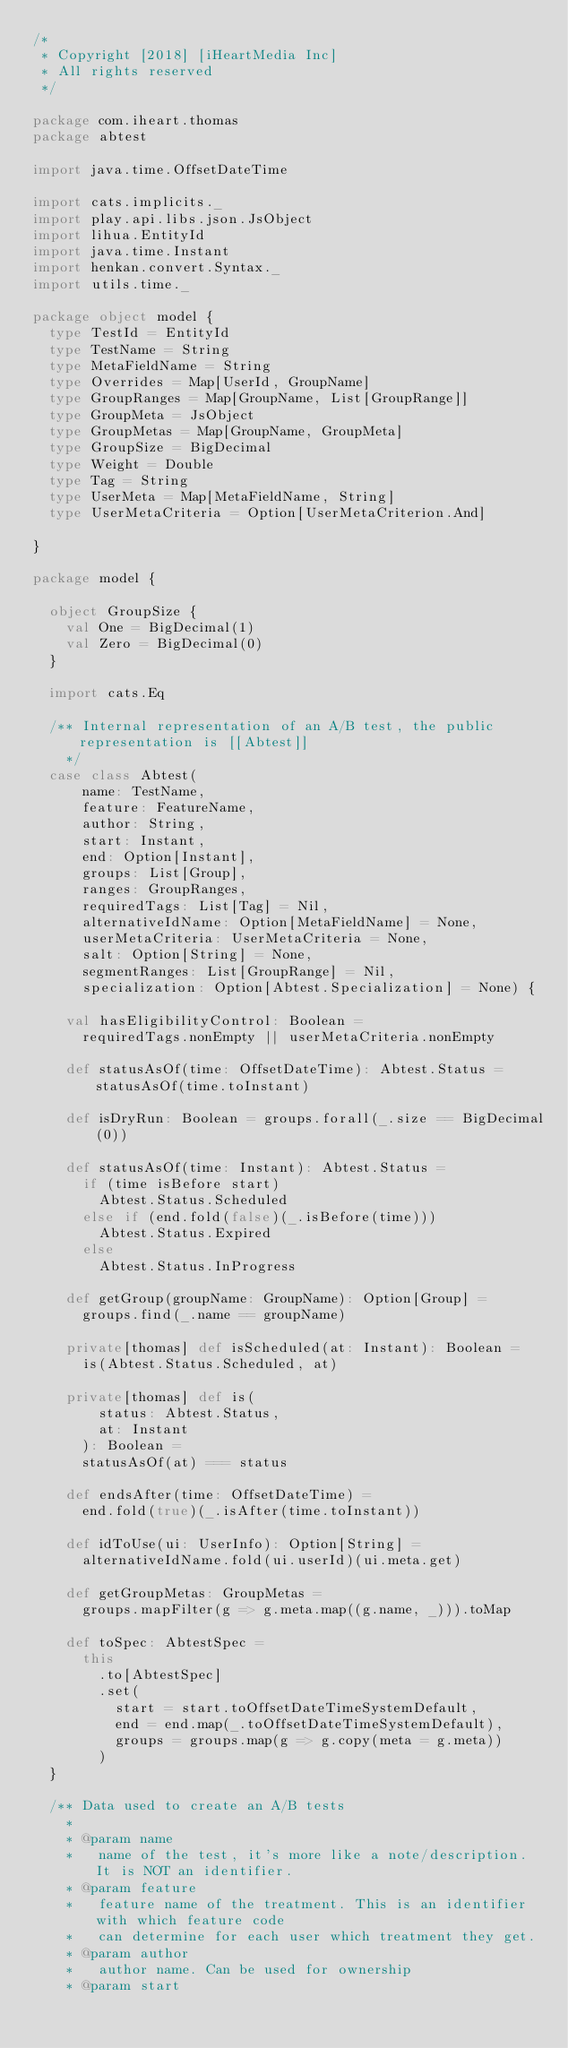Convert code to text. <code><loc_0><loc_0><loc_500><loc_500><_Scala_>/*
 * Copyright [2018] [iHeartMedia Inc]
 * All rights reserved
 */

package com.iheart.thomas
package abtest

import java.time.OffsetDateTime

import cats.implicits._
import play.api.libs.json.JsObject
import lihua.EntityId
import java.time.Instant
import henkan.convert.Syntax._
import utils.time._

package object model {
  type TestId = EntityId
  type TestName = String
  type MetaFieldName = String
  type Overrides = Map[UserId, GroupName]
  type GroupRanges = Map[GroupName, List[GroupRange]]
  type GroupMeta = JsObject
  type GroupMetas = Map[GroupName, GroupMeta]
  type GroupSize = BigDecimal
  type Weight = Double
  type Tag = String
  type UserMeta = Map[MetaFieldName, String]
  type UserMetaCriteria = Option[UserMetaCriterion.And]

}

package model {

  object GroupSize {
    val One = BigDecimal(1)
    val Zero = BigDecimal(0)
  }

  import cats.Eq

  /** Internal representation of an A/B test, the public representation is [[Abtest]]
    */
  case class Abtest(
      name: TestName,
      feature: FeatureName,
      author: String,
      start: Instant,
      end: Option[Instant],
      groups: List[Group],
      ranges: GroupRanges,
      requiredTags: List[Tag] = Nil,
      alternativeIdName: Option[MetaFieldName] = None,
      userMetaCriteria: UserMetaCriteria = None,
      salt: Option[String] = None,
      segmentRanges: List[GroupRange] = Nil,
      specialization: Option[Abtest.Specialization] = None) {

    val hasEligibilityControl: Boolean =
      requiredTags.nonEmpty || userMetaCriteria.nonEmpty

    def statusAsOf(time: OffsetDateTime): Abtest.Status = statusAsOf(time.toInstant)

    def isDryRun: Boolean = groups.forall(_.size == BigDecimal(0))

    def statusAsOf(time: Instant): Abtest.Status =
      if (time isBefore start)
        Abtest.Status.Scheduled
      else if (end.fold(false)(_.isBefore(time)))
        Abtest.Status.Expired
      else
        Abtest.Status.InProgress

    def getGroup(groupName: GroupName): Option[Group] =
      groups.find(_.name == groupName)

    private[thomas] def isScheduled(at: Instant): Boolean =
      is(Abtest.Status.Scheduled, at)

    private[thomas] def is(
        status: Abtest.Status,
        at: Instant
      ): Boolean =
      statusAsOf(at) === status

    def endsAfter(time: OffsetDateTime) =
      end.fold(true)(_.isAfter(time.toInstant))

    def idToUse(ui: UserInfo): Option[String] =
      alternativeIdName.fold(ui.userId)(ui.meta.get)

    def getGroupMetas: GroupMetas =
      groups.mapFilter(g => g.meta.map((g.name, _))).toMap

    def toSpec: AbtestSpec =
      this
        .to[AbtestSpec]
        .set(
          start = start.toOffsetDateTimeSystemDefault,
          end = end.map(_.toOffsetDateTimeSystemDefault),
          groups = groups.map(g => g.copy(meta = g.meta))
        )
  }

  /** Data used to create an A/B tests
    *
    * @param name
    *   name of the test, it's more like a note/description. It is NOT an identifier.
    * @param feature
    *   feature name of the treatment. This is an identifier with which feature code
    *   can determine for each user which treatment they get.
    * @param author
    *   author name. Can be used for ownership
    * @param start</code> 